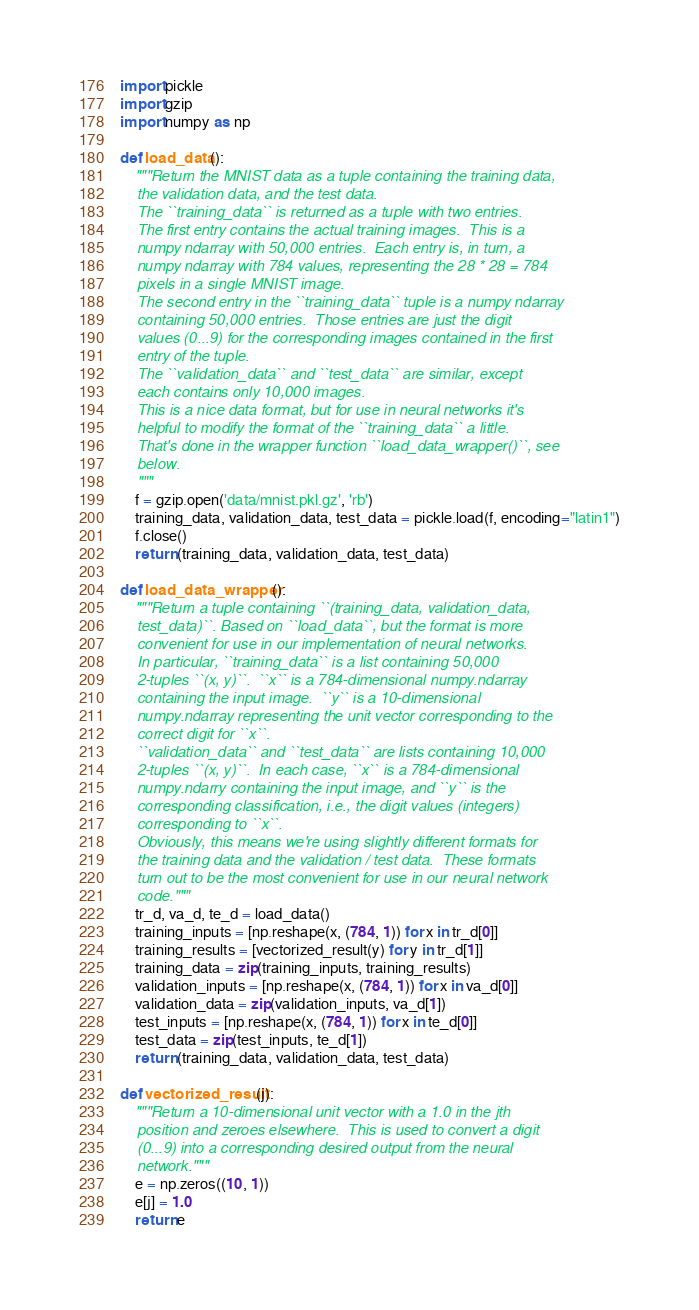<code> <loc_0><loc_0><loc_500><loc_500><_Python_>import pickle
import gzip
import numpy as np

def load_data():
    """Return the MNIST data as a tuple containing the training data,
    the validation data, and the test data.
    The ``training_data`` is returned as a tuple with two entries.
    The first entry contains the actual training images.  This is a
    numpy ndarray with 50,000 entries.  Each entry is, in turn, a
    numpy ndarray with 784 values, representing the 28 * 28 = 784
    pixels in a single MNIST image.
    The second entry in the ``training_data`` tuple is a numpy ndarray
    containing 50,000 entries.  Those entries are just the digit
    values (0...9) for the corresponding images contained in the first
    entry of the tuple.
    The ``validation_data`` and ``test_data`` are similar, except
    each contains only 10,000 images.
    This is a nice data format, but for use in neural networks it's
    helpful to modify the format of the ``training_data`` a little.
    That's done in the wrapper function ``load_data_wrapper()``, see
    below.
    """
    f = gzip.open('data/mnist.pkl.gz', 'rb')
    training_data, validation_data, test_data = pickle.load(f, encoding="latin1")
    f.close()
    return (training_data, validation_data, test_data)

def load_data_wrapper():
    """Return a tuple containing ``(training_data, validation_data,
    test_data)``. Based on ``load_data``, but the format is more
    convenient for use in our implementation of neural networks.
    In particular, ``training_data`` is a list containing 50,000
    2-tuples ``(x, y)``.  ``x`` is a 784-dimensional numpy.ndarray
    containing the input image.  ``y`` is a 10-dimensional
    numpy.ndarray representing the unit vector corresponding to the
    correct digit for ``x``.
    ``validation_data`` and ``test_data`` are lists containing 10,000
    2-tuples ``(x, y)``.  In each case, ``x`` is a 784-dimensional
    numpy.ndarry containing the input image, and ``y`` is the
    corresponding classification, i.e., the digit values (integers)
    corresponding to ``x``.
    Obviously, this means we're using slightly different formats for
    the training data and the validation / test data.  These formats
    turn out to be the most convenient for use in our neural network
    code."""
    tr_d, va_d, te_d = load_data()
    training_inputs = [np.reshape(x, (784, 1)) for x in tr_d[0]]
    training_results = [vectorized_result(y) for y in tr_d[1]]
    training_data = zip(training_inputs, training_results)
    validation_inputs = [np.reshape(x, (784, 1)) for x in va_d[0]]
    validation_data = zip(validation_inputs, va_d[1])
    test_inputs = [np.reshape(x, (784, 1)) for x in te_d[0]]
    test_data = zip(test_inputs, te_d[1])
    return (training_data, validation_data, test_data)

def vectorized_result(j):
    """Return a 10-dimensional unit vector with a 1.0 in the jth
    position and zeroes elsewhere.  This is used to convert a digit
    (0...9) into a corresponding desired output from the neural
    network."""
    e = np.zeros((10, 1))
    e[j] = 1.0
    return e
</code> 